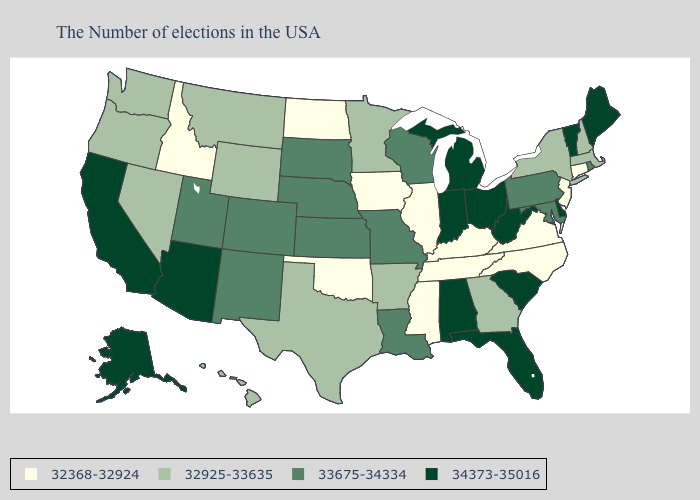What is the value of Tennessee?
Short answer required. 32368-32924. Among the states that border New York , does Massachusetts have the lowest value?
Quick response, please. No. Name the states that have a value in the range 34373-35016?
Keep it brief. Maine, Vermont, Delaware, South Carolina, West Virginia, Ohio, Florida, Michigan, Indiana, Alabama, Arizona, California, Alaska. What is the value of North Dakota?
Short answer required. 32368-32924. Does the first symbol in the legend represent the smallest category?
Give a very brief answer. Yes. What is the lowest value in the West?
Short answer required. 32368-32924. What is the lowest value in states that border Maine?
Short answer required. 32925-33635. Among the states that border Idaho , does Utah have the highest value?
Answer briefly. Yes. What is the highest value in the Northeast ?
Quick response, please. 34373-35016. Among the states that border Pennsylvania , which have the lowest value?
Quick response, please. New Jersey. What is the value of Alaska?
Concise answer only. 34373-35016. Does the map have missing data?
Give a very brief answer. No. Does Arkansas have a higher value than Kansas?
Short answer required. No. Name the states that have a value in the range 33675-34334?
Be succinct. Rhode Island, Maryland, Pennsylvania, Wisconsin, Louisiana, Missouri, Kansas, Nebraska, South Dakota, Colorado, New Mexico, Utah. Does Maryland have a higher value than California?
Keep it brief. No. 